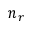Convert formula to latex. <formula><loc_0><loc_0><loc_500><loc_500>n _ { r }</formula> 